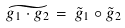Convert formula to latex. <formula><loc_0><loc_0><loc_500><loc_500>\widetilde { g _ { 1 } \cdot g _ { 2 } } \, = \, \tilde { g } _ { 1 } \circ \tilde { g } _ { 2 }</formula> 